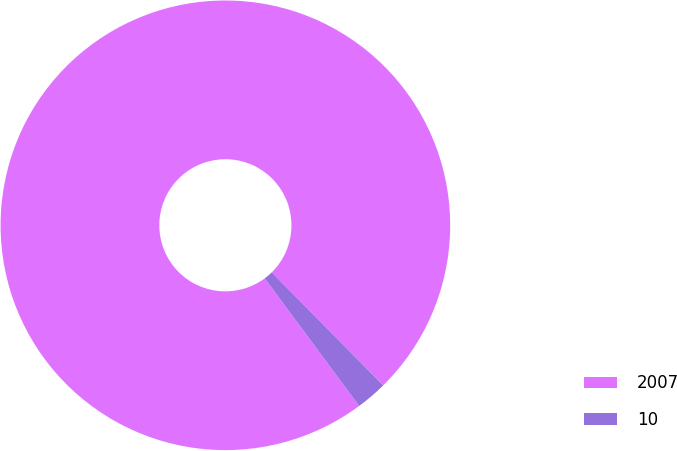Convert chart to OTSL. <chart><loc_0><loc_0><loc_500><loc_500><pie_chart><fcel>2007<fcel>10<nl><fcel>97.76%<fcel>2.24%<nl></chart> 